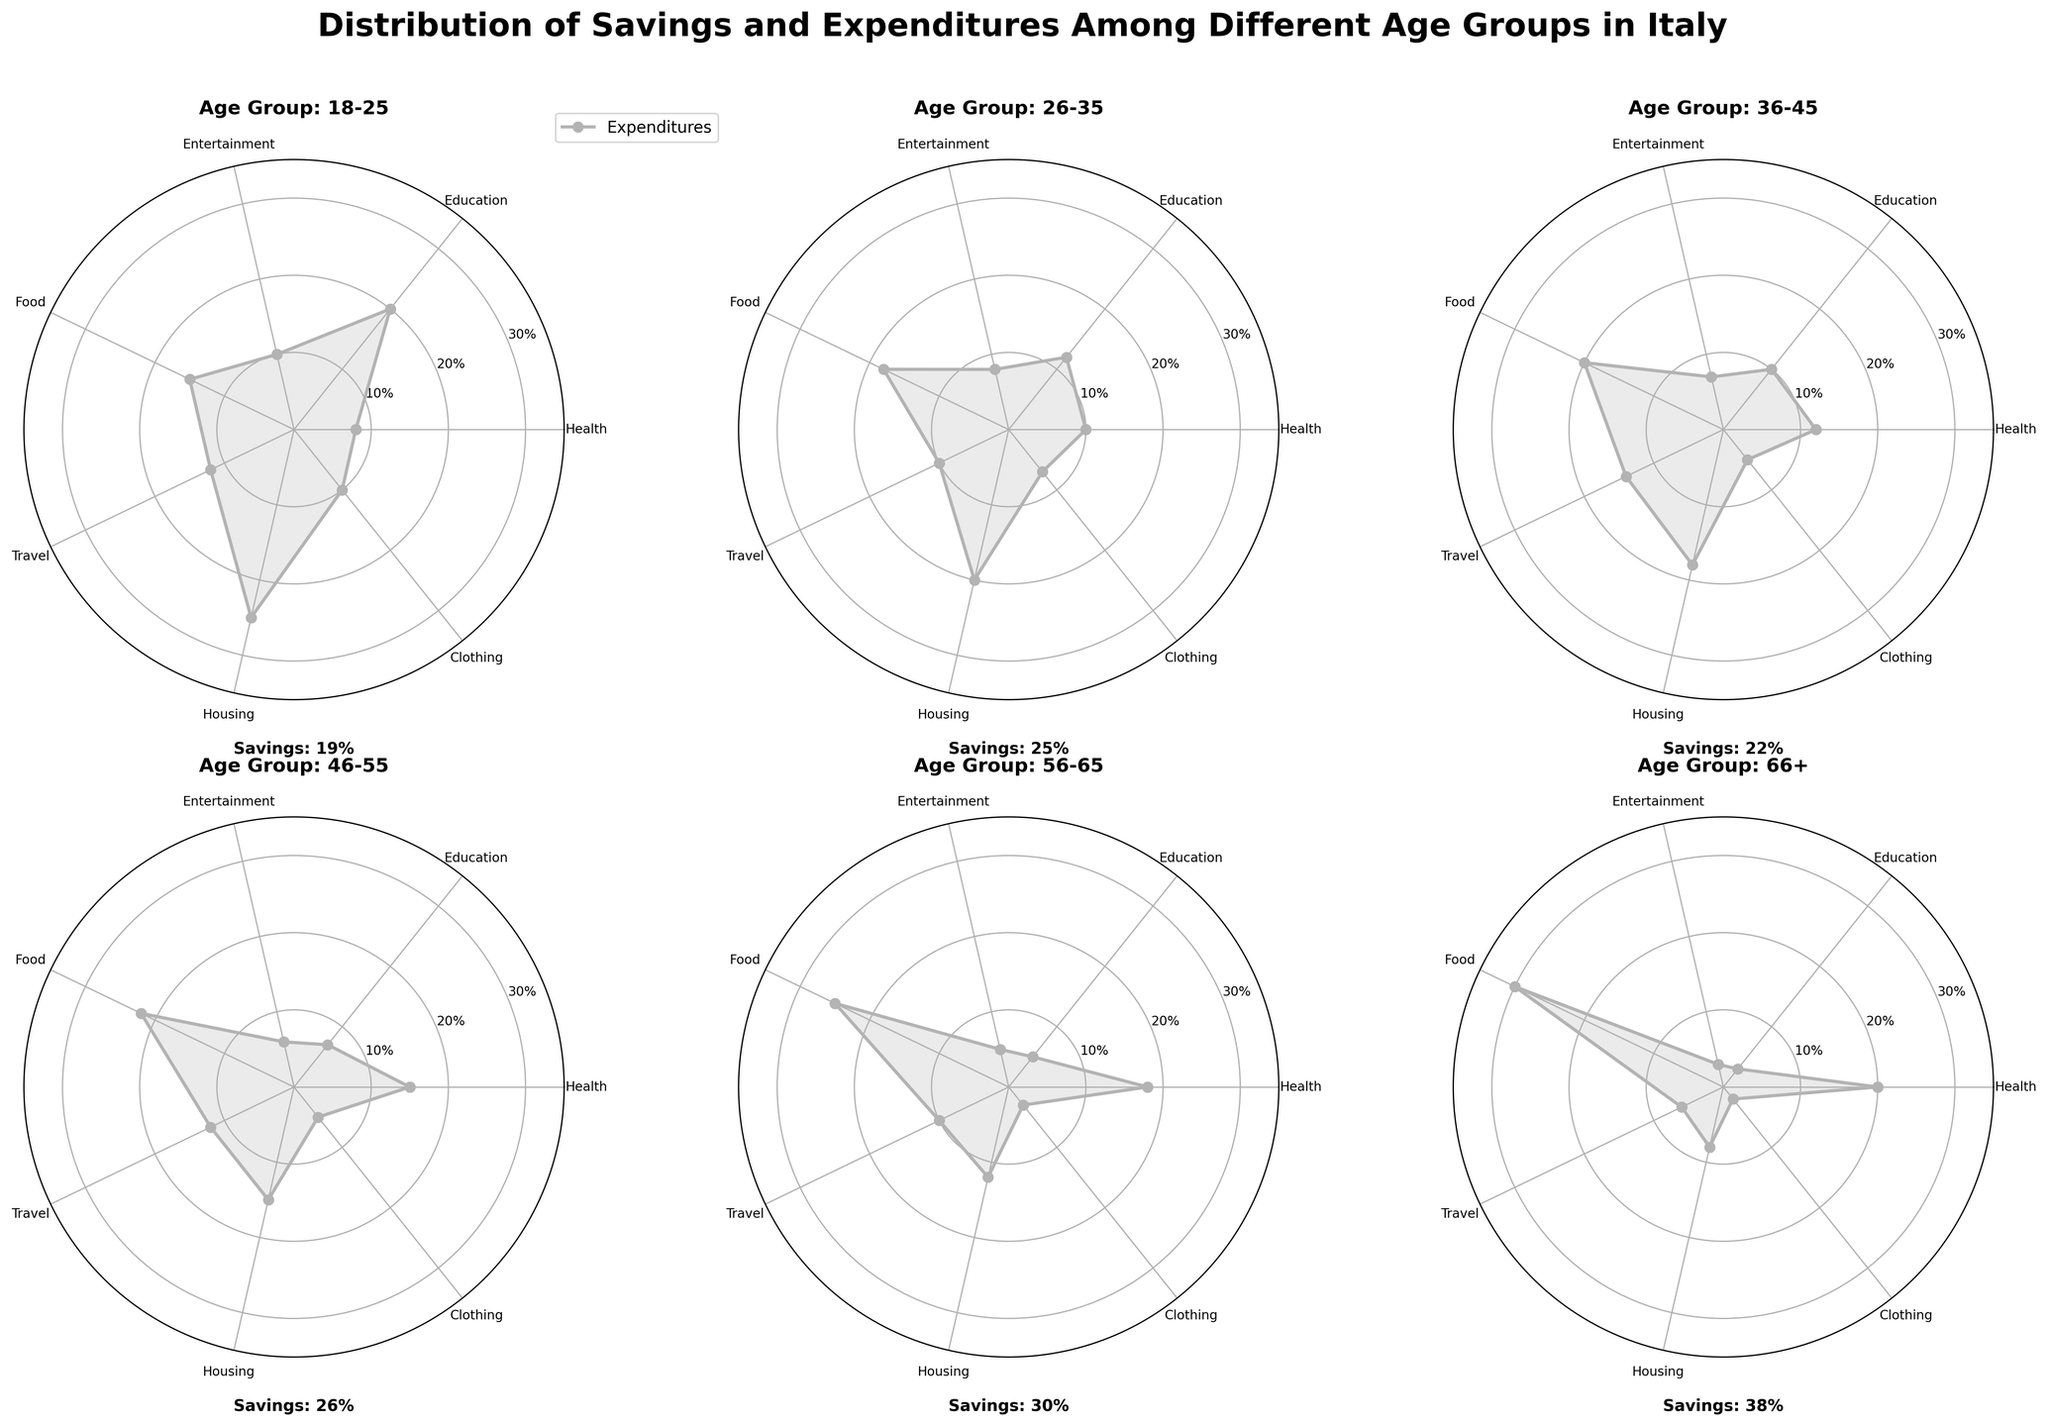What is the title of the figure? The title is located at the top of the figure and usually describes the overall content it represents. In this case, it informs the viewer about the data's theme.
Answer: Distribution of Savings and Expenditures Among Different Age Groups in Italy Which age group has the highest percentage of savings? Each subplot (one for each age group) has a text description indicating the percentage of savings at the bottom. By comparing these values, we can see which one is the highest.
Answer: 66+ Which category has the highest expenditure percentage for the age group 66+? By looking at the angular points on the radar chart specific to the 66+ age group, you can see the highest-percentage value. The category aligned with this peak is the highest expenditure.
Answer: Food How do the expenditures in the Travel category compare between the 18-25 and 56-65 age groups? The Travel category expenditures for each age group can be found by looking at their respective points on the radar charts. By comparing these, you'll see how these two age groups allocate their expenditures on travel.
Answer: 12% (18-25) and 10% (56-65) What is the difference in the Health expenditures between the 46-55 and 66+ age groups? To find this difference, check the Health category expenditures in the radar charts for both age groups and subtract the smaller percentage from the larger one.
Answer: 5% Which age group spends the least on Clothing? Examine the radar charts for each age group's Clothing expenditure and identify the one with the lowest value.
Answer: 66+ Which two categories have the closest percentage expenditures for the age group 36-45? By comparing the values directly from the radar chart of the 36-45 age group, look for the two categories where the expenditure percentages are most similar to each other.
Answer: Clothing and Entertainment Does any age group spend the same percentage in two different categories? You need to thoroughly check the percentages in all categories for each age group to identify if there are any identical values within the same age group.
Answer: No Which age group has the most balanced expenditure distribution across all categories? Find the age group whose radar chart appears most circular and uniform, suggesting more evenly distributed expenditures across categories.
Answer: 26-35 What is the total percentage of expenditures in Housing and Food for the 26-35 age group? Add the percentage values of Housing and Food categories for the 26-35 age group from the radar chart to get the total.
Answer: 38% 